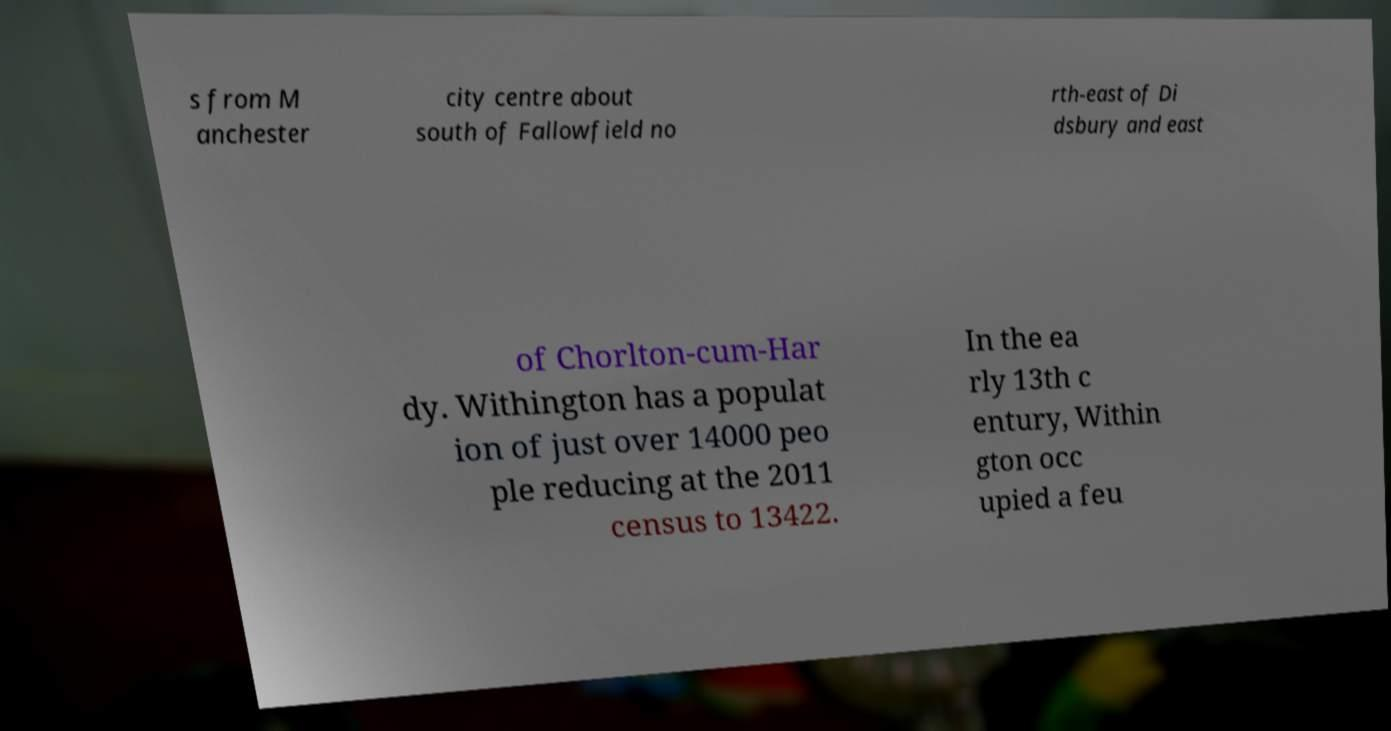Can you read and provide the text displayed in the image?This photo seems to have some interesting text. Can you extract and type it out for me? s from M anchester city centre about south of Fallowfield no rth-east of Di dsbury and east of Chorlton-cum-Har dy. Withington has a populat ion of just over 14000 peo ple reducing at the 2011 census to 13422. In the ea rly 13th c entury, Within gton occ upied a feu 